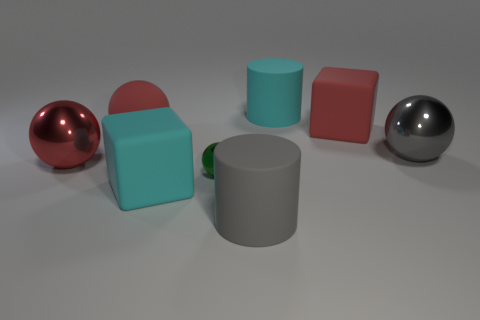Can you tell me what materials the objects in the image seem to be made of? Certainly. The objects showcase a variety of textures that suggest they are made from different materials. The red and silver spherical objects have reflective surfaces indicative of polished metals, while the turquoise and pink shapes appear to have a matte finish, which could suggest a plastic or ceramic material. The gray cylindrical object in the center also has a matte finish, and its neutral color suggests it might be made of stone or concrete. 